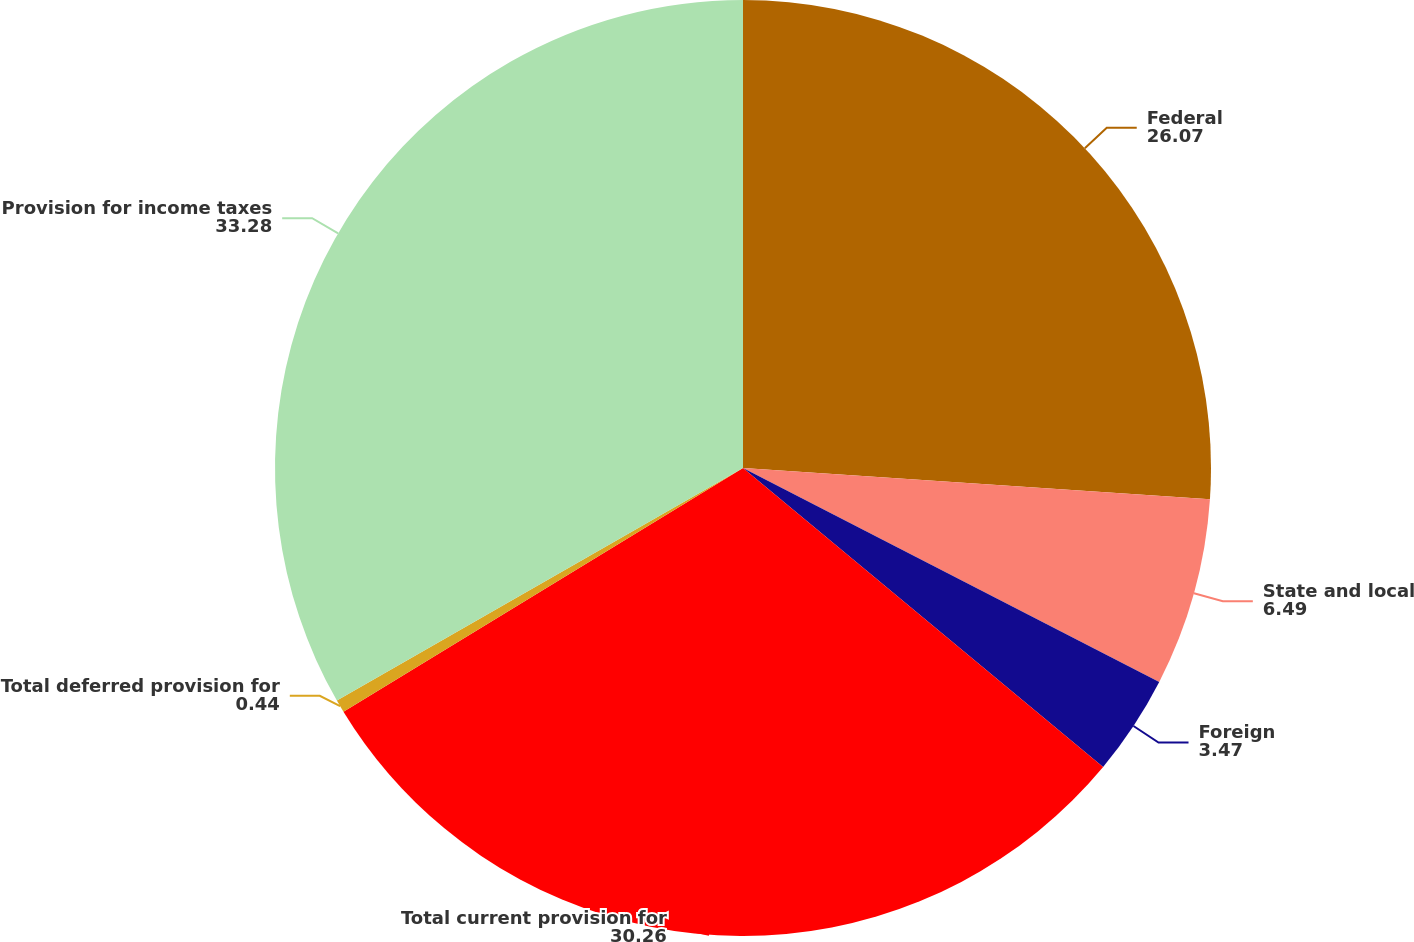<chart> <loc_0><loc_0><loc_500><loc_500><pie_chart><fcel>Federal<fcel>State and local<fcel>Foreign<fcel>Total current provision for<fcel>Total deferred provision for<fcel>Provision for income taxes<nl><fcel>26.07%<fcel>6.49%<fcel>3.47%<fcel>30.26%<fcel>0.44%<fcel>33.28%<nl></chart> 